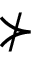<formula> <loc_0><loc_0><loc_500><loc_500>\nsucc</formula> 